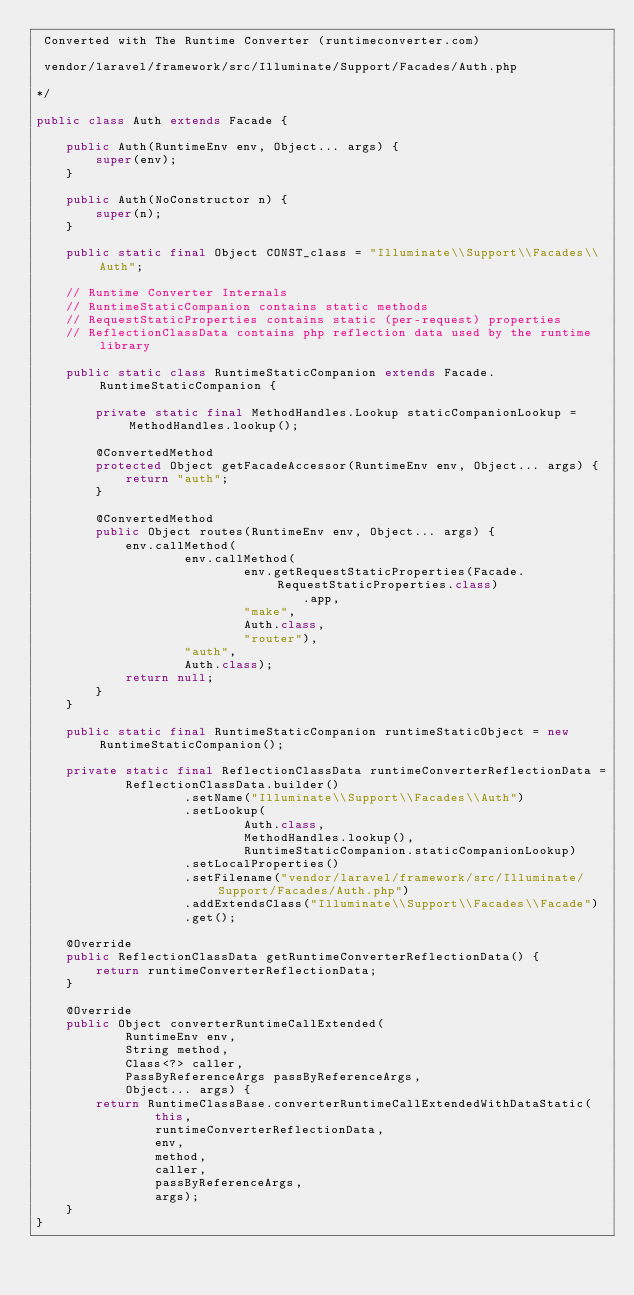<code> <loc_0><loc_0><loc_500><loc_500><_Java_> Converted with The Runtime Converter (runtimeconverter.com)

 vendor/laravel/framework/src/Illuminate/Support/Facades/Auth.php

*/

public class Auth extends Facade {

    public Auth(RuntimeEnv env, Object... args) {
        super(env);
    }

    public Auth(NoConstructor n) {
        super(n);
    }

    public static final Object CONST_class = "Illuminate\\Support\\Facades\\Auth";

    // Runtime Converter Internals
    // RuntimeStaticCompanion contains static methods
    // RequestStaticProperties contains static (per-request) properties
    // ReflectionClassData contains php reflection data used by the runtime library

    public static class RuntimeStaticCompanion extends Facade.RuntimeStaticCompanion {

        private static final MethodHandles.Lookup staticCompanionLookup = MethodHandles.lookup();

        @ConvertedMethod
        protected Object getFacadeAccessor(RuntimeEnv env, Object... args) {
            return "auth";
        }

        @ConvertedMethod
        public Object routes(RuntimeEnv env, Object... args) {
            env.callMethod(
                    env.callMethod(
                            env.getRequestStaticProperties(Facade.RequestStaticProperties.class)
                                    .app,
                            "make",
                            Auth.class,
                            "router"),
                    "auth",
                    Auth.class);
            return null;
        }
    }

    public static final RuntimeStaticCompanion runtimeStaticObject = new RuntimeStaticCompanion();

    private static final ReflectionClassData runtimeConverterReflectionData =
            ReflectionClassData.builder()
                    .setName("Illuminate\\Support\\Facades\\Auth")
                    .setLookup(
                            Auth.class,
                            MethodHandles.lookup(),
                            RuntimeStaticCompanion.staticCompanionLookup)
                    .setLocalProperties()
                    .setFilename("vendor/laravel/framework/src/Illuminate/Support/Facades/Auth.php")
                    .addExtendsClass("Illuminate\\Support\\Facades\\Facade")
                    .get();

    @Override
    public ReflectionClassData getRuntimeConverterReflectionData() {
        return runtimeConverterReflectionData;
    }

    @Override
    public Object converterRuntimeCallExtended(
            RuntimeEnv env,
            String method,
            Class<?> caller,
            PassByReferenceArgs passByReferenceArgs,
            Object... args) {
        return RuntimeClassBase.converterRuntimeCallExtendedWithDataStatic(
                this,
                runtimeConverterReflectionData,
                env,
                method,
                caller,
                passByReferenceArgs,
                args);
    }
}
</code> 